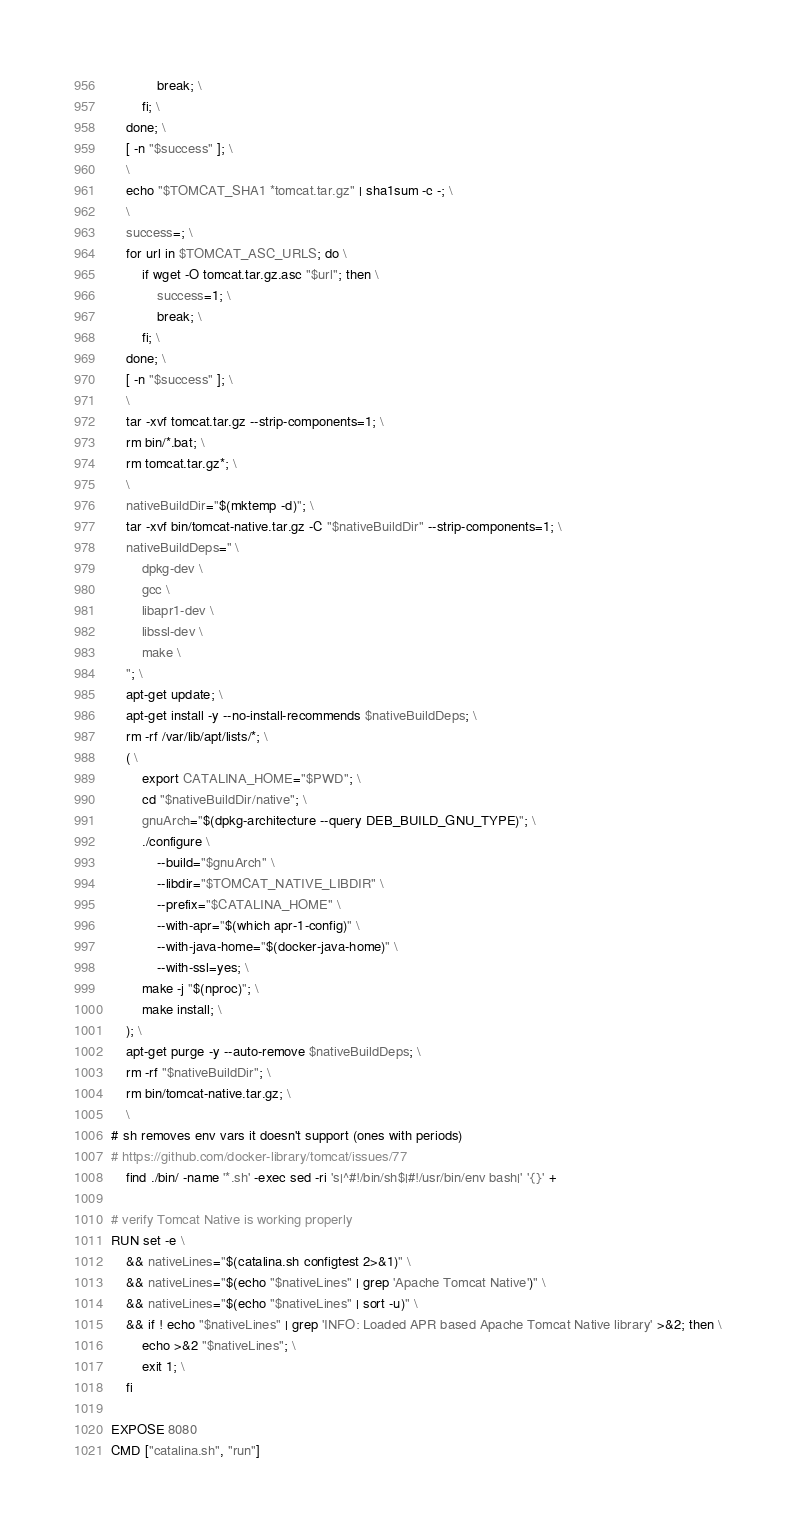<code> <loc_0><loc_0><loc_500><loc_500><_Dockerfile_>			break; \
		fi; \
	done; \
	[ -n "$success" ]; \
	\
	echo "$TOMCAT_SHA1 *tomcat.tar.gz" | sha1sum -c -; \
	\
	success=; \
	for url in $TOMCAT_ASC_URLS; do \
		if wget -O tomcat.tar.gz.asc "$url"; then \
			success=1; \
			break; \
		fi; \
	done; \
	[ -n "$success" ]; \
	\
	tar -xvf tomcat.tar.gz --strip-components=1; \
	rm bin/*.bat; \
	rm tomcat.tar.gz*; \
	\
	nativeBuildDir="$(mktemp -d)"; \
	tar -xvf bin/tomcat-native.tar.gz -C "$nativeBuildDir" --strip-components=1; \
	nativeBuildDeps=" \
		dpkg-dev \
		gcc \
		libapr1-dev \
		libssl-dev \
		make \
	"; \
	apt-get update; \
	apt-get install -y --no-install-recommends $nativeBuildDeps; \
	rm -rf /var/lib/apt/lists/*; \
	( \
		export CATALINA_HOME="$PWD"; \
		cd "$nativeBuildDir/native"; \
		gnuArch="$(dpkg-architecture --query DEB_BUILD_GNU_TYPE)"; \
		./configure \
			--build="$gnuArch" \
			--libdir="$TOMCAT_NATIVE_LIBDIR" \
			--prefix="$CATALINA_HOME" \
			--with-apr="$(which apr-1-config)" \
			--with-java-home="$(docker-java-home)" \
			--with-ssl=yes; \
		make -j "$(nproc)"; \
		make install; \
	); \
	apt-get purge -y --auto-remove $nativeBuildDeps; \
	rm -rf "$nativeBuildDir"; \
	rm bin/tomcat-native.tar.gz; \
	\
# sh removes env vars it doesn't support (ones with periods)
# https://github.com/docker-library/tomcat/issues/77
	find ./bin/ -name '*.sh' -exec sed -ri 's|^#!/bin/sh$|#!/usr/bin/env bash|' '{}' +

# verify Tomcat Native is working properly
RUN set -e \
	&& nativeLines="$(catalina.sh configtest 2>&1)" \
	&& nativeLines="$(echo "$nativeLines" | grep 'Apache Tomcat Native')" \
	&& nativeLines="$(echo "$nativeLines" | sort -u)" \
	&& if ! echo "$nativeLines" | grep 'INFO: Loaded APR based Apache Tomcat Native library' >&2; then \
		echo >&2 "$nativeLines"; \
		exit 1; \
	fi

EXPOSE 8080
CMD ["catalina.sh", "run"]
</code> 